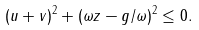<formula> <loc_0><loc_0><loc_500><loc_500>( u + v ) ^ { 2 } + ( \omega z - g / \omega ) ^ { 2 } \leq 0 .</formula> 